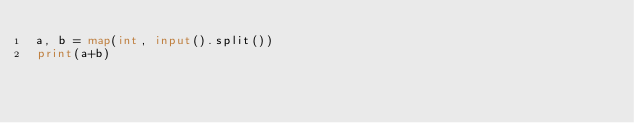Convert code to text. <code><loc_0><loc_0><loc_500><loc_500><_Python_>a, b = map(int, input().split())
print(a+b)</code> 